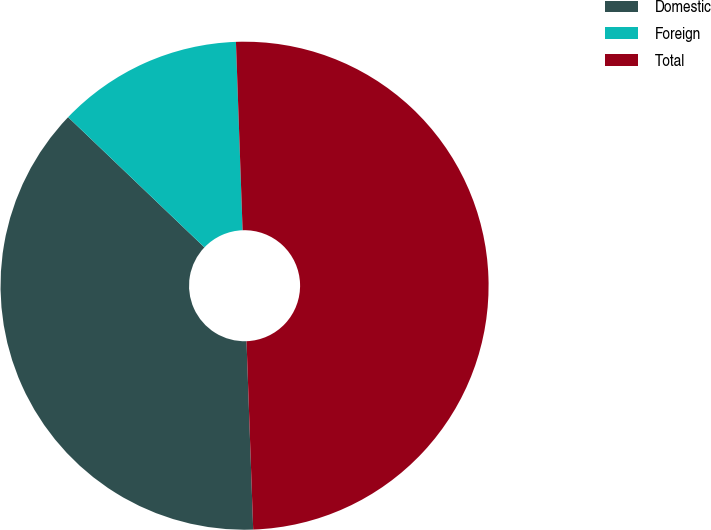Convert chart. <chart><loc_0><loc_0><loc_500><loc_500><pie_chart><fcel>Domestic<fcel>Foreign<fcel>Total<nl><fcel>37.7%<fcel>12.3%<fcel>50.0%<nl></chart> 